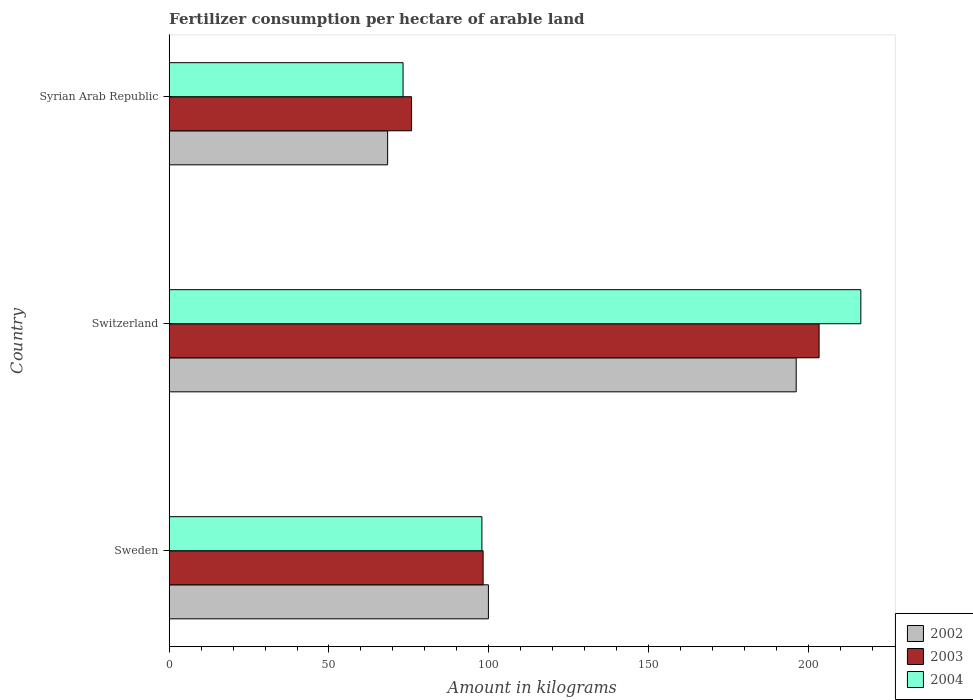How many bars are there on the 1st tick from the top?
Offer a very short reply. 3. What is the label of the 3rd group of bars from the top?
Offer a terse response. Sweden. What is the amount of fertilizer consumption in 2003 in Sweden?
Your response must be concise. 98.24. Across all countries, what is the maximum amount of fertilizer consumption in 2003?
Keep it short and to the point. 203.37. Across all countries, what is the minimum amount of fertilizer consumption in 2003?
Offer a very short reply. 75.85. In which country was the amount of fertilizer consumption in 2003 maximum?
Ensure brevity in your answer.  Switzerland. In which country was the amount of fertilizer consumption in 2004 minimum?
Your response must be concise. Syrian Arab Republic. What is the total amount of fertilizer consumption in 2002 in the graph?
Offer a very short reply. 364.45. What is the difference between the amount of fertilizer consumption in 2003 in Sweden and that in Syrian Arab Republic?
Offer a terse response. 22.39. What is the difference between the amount of fertilizer consumption in 2003 in Syrian Arab Republic and the amount of fertilizer consumption in 2002 in Sweden?
Your answer should be very brief. -24.04. What is the average amount of fertilizer consumption in 2002 per country?
Provide a succinct answer. 121.48. What is the difference between the amount of fertilizer consumption in 2003 and amount of fertilizer consumption in 2004 in Syrian Arab Republic?
Keep it short and to the point. 2.67. In how many countries, is the amount of fertilizer consumption in 2002 greater than 170 kg?
Your answer should be very brief. 1. What is the ratio of the amount of fertilizer consumption in 2002 in Switzerland to that in Syrian Arab Republic?
Give a very brief answer. 2.87. What is the difference between the highest and the second highest amount of fertilizer consumption in 2003?
Keep it short and to the point. 105.13. What is the difference between the highest and the lowest amount of fertilizer consumption in 2002?
Offer a terse response. 127.85. In how many countries, is the amount of fertilizer consumption in 2002 greater than the average amount of fertilizer consumption in 2002 taken over all countries?
Your response must be concise. 1. What does the 1st bar from the top in Syrian Arab Republic represents?
Offer a very short reply. 2004. What does the 2nd bar from the bottom in Syrian Arab Republic represents?
Your response must be concise. 2003. Is it the case that in every country, the sum of the amount of fertilizer consumption in 2004 and amount of fertilizer consumption in 2002 is greater than the amount of fertilizer consumption in 2003?
Make the answer very short. Yes. How many bars are there?
Offer a very short reply. 9. Are all the bars in the graph horizontal?
Keep it short and to the point. Yes. How many countries are there in the graph?
Your answer should be very brief. 3. Are the values on the major ticks of X-axis written in scientific E-notation?
Provide a succinct answer. No. Does the graph contain any zero values?
Your response must be concise. No. Does the graph contain grids?
Your answer should be very brief. No. Where does the legend appear in the graph?
Provide a short and direct response. Bottom right. How many legend labels are there?
Keep it short and to the point. 3. How are the legend labels stacked?
Your answer should be very brief. Vertical. What is the title of the graph?
Your answer should be very brief. Fertilizer consumption per hectare of arable land. Does "2006" appear as one of the legend labels in the graph?
Offer a terse response. No. What is the label or title of the X-axis?
Provide a succinct answer. Amount in kilograms. What is the label or title of the Y-axis?
Your answer should be very brief. Country. What is the Amount in kilograms in 2002 in Sweden?
Your answer should be compact. 99.89. What is the Amount in kilograms of 2003 in Sweden?
Make the answer very short. 98.24. What is the Amount in kilograms in 2004 in Sweden?
Your answer should be compact. 97.85. What is the Amount in kilograms of 2002 in Switzerland?
Give a very brief answer. 196.21. What is the Amount in kilograms of 2003 in Switzerland?
Your answer should be compact. 203.37. What is the Amount in kilograms in 2004 in Switzerland?
Give a very brief answer. 216.44. What is the Amount in kilograms of 2002 in Syrian Arab Republic?
Provide a short and direct response. 68.35. What is the Amount in kilograms in 2003 in Syrian Arab Republic?
Provide a succinct answer. 75.85. What is the Amount in kilograms in 2004 in Syrian Arab Republic?
Offer a very short reply. 73.18. Across all countries, what is the maximum Amount in kilograms in 2002?
Ensure brevity in your answer.  196.21. Across all countries, what is the maximum Amount in kilograms in 2003?
Ensure brevity in your answer.  203.37. Across all countries, what is the maximum Amount in kilograms of 2004?
Ensure brevity in your answer.  216.44. Across all countries, what is the minimum Amount in kilograms in 2002?
Make the answer very short. 68.35. Across all countries, what is the minimum Amount in kilograms of 2003?
Your answer should be compact. 75.85. Across all countries, what is the minimum Amount in kilograms in 2004?
Your response must be concise. 73.18. What is the total Amount in kilograms in 2002 in the graph?
Provide a succinct answer. 364.45. What is the total Amount in kilograms in 2003 in the graph?
Give a very brief answer. 377.46. What is the total Amount in kilograms in 2004 in the graph?
Give a very brief answer. 387.47. What is the difference between the Amount in kilograms in 2002 in Sweden and that in Switzerland?
Your answer should be very brief. -96.32. What is the difference between the Amount in kilograms in 2003 in Sweden and that in Switzerland?
Provide a succinct answer. -105.13. What is the difference between the Amount in kilograms in 2004 in Sweden and that in Switzerland?
Give a very brief answer. -118.58. What is the difference between the Amount in kilograms in 2002 in Sweden and that in Syrian Arab Republic?
Keep it short and to the point. 31.54. What is the difference between the Amount in kilograms of 2003 in Sweden and that in Syrian Arab Republic?
Give a very brief answer. 22.39. What is the difference between the Amount in kilograms in 2004 in Sweden and that in Syrian Arab Republic?
Give a very brief answer. 24.67. What is the difference between the Amount in kilograms of 2002 in Switzerland and that in Syrian Arab Republic?
Keep it short and to the point. 127.85. What is the difference between the Amount in kilograms of 2003 in Switzerland and that in Syrian Arab Republic?
Keep it short and to the point. 127.52. What is the difference between the Amount in kilograms of 2004 in Switzerland and that in Syrian Arab Republic?
Offer a terse response. 143.26. What is the difference between the Amount in kilograms in 2002 in Sweden and the Amount in kilograms in 2003 in Switzerland?
Your response must be concise. -103.48. What is the difference between the Amount in kilograms of 2002 in Sweden and the Amount in kilograms of 2004 in Switzerland?
Your answer should be very brief. -116.55. What is the difference between the Amount in kilograms in 2003 in Sweden and the Amount in kilograms in 2004 in Switzerland?
Provide a succinct answer. -118.2. What is the difference between the Amount in kilograms in 2002 in Sweden and the Amount in kilograms in 2003 in Syrian Arab Republic?
Offer a terse response. 24.04. What is the difference between the Amount in kilograms in 2002 in Sweden and the Amount in kilograms in 2004 in Syrian Arab Republic?
Your answer should be compact. 26.71. What is the difference between the Amount in kilograms in 2003 in Sweden and the Amount in kilograms in 2004 in Syrian Arab Republic?
Make the answer very short. 25.06. What is the difference between the Amount in kilograms in 2002 in Switzerland and the Amount in kilograms in 2003 in Syrian Arab Republic?
Give a very brief answer. 120.36. What is the difference between the Amount in kilograms of 2002 in Switzerland and the Amount in kilograms of 2004 in Syrian Arab Republic?
Provide a succinct answer. 123.03. What is the difference between the Amount in kilograms of 2003 in Switzerland and the Amount in kilograms of 2004 in Syrian Arab Republic?
Offer a terse response. 130.19. What is the average Amount in kilograms in 2002 per country?
Make the answer very short. 121.48. What is the average Amount in kilograms of 2003 per country?
Make the answer very short. 125.82. What is the average Amount in kilograms of 2004 per country?
Make the answer very short. 129.16. What is the difference between the Amount in kilograms in 2002 and Amount in kilograms in 2003 in Sweden?
Give a very brief answer. 1.65. What is the difference between the Amount in kilograms in 2002 and Amount in kilograms in 2004 in Sweden?
Ensure brevity in your answer.  2.03. What is the difference between the Amount in kilograms in 2003 and Amount in kilograms in 2004 in Sweden?
Offer a very short reply. 0.38. What is the difference between the Amount in kilograms in 2002 and Amount in kilograms in 2003 in Switzerland?
Provide a succinct answer. -7.16. What is the difference between the Amount in kilograms in 2002 and Amount in kilograms in 2004 in Switzerland?
Make the answer very short. -20.23. What is the difference between the Amount in kilograms of 2003 and Amount in kilograms of 2004 in Switzerland?
Provide a short and direct response. -13.07. What is the difference between the Amount in kilograms in 2002 and Amount in kilograms in 2003 in Syrian Arab Republic?
Ensure brevity in your answer.  -7.5. What is the difference between the Amount in kilograms in 2002 and Amount in kilograms in 2004 in Syrian Arab Republic?
Offer a very short reply. -4.83. What is the difference between the Amount in kilograms of 2003 and Amount in kilograms of 2004 in Syrian Arab Republic?
Ensure brevity in your answer.  2.67. What is the ratio of the Amount in kilograms in 2002 in Sweden to that in Switzerland?
Offer a very short reply. 0.51. What is the ratio of the Amount in kilograms of 2003 in Sweden to that in Switzerland?
Keep it short and to the point. 0.48. What is the ratio of the Amount in kilograms of 2004 in Sweden to that in Switzerland?
Make the answer very short. 0.45. What is the ratio of the Amount in kilograms in 2002 in Sweden to that in Syrian Arab Republic?
Provide a succinct answer. 1.46. What is the ratio of the Amount in kilograms in 2003 in Sweden to that in Syrian Arab Republic?
Give a very brief answer. 1.3. What is the ratio of the Amount in kilograms in 2004 in Sweden to that in Syrian Arab Republic?
Keep it short and to the point. 1.34. What is the ratio of the Amount in kilograms of 2002 in Switzerland to that in Syrian Arab Republic?
Make the answer very short. 2.87. What is the ratio of the Amount in kilograms in 2003 in Switzerland to that in Syrian Arab Republic?
Your answer should be very brief. 2.68. What is the ratio of the Amount in kilograms in 2004 in Switzerland to that in Syrian Arab Republic?
Give a very brief answer. 2.96. What is the difference between the highest and the second highest Amount in kilograms of 2002?
Your response must be concise. 96.32. What is the difference between the highest and the second highest Amount in kilograms in 2003?
Keep it short and to the point. 105.13. What is the difference between the highest and the second highest Amount in kilograms of 2004?
Your answer should be compact. 118.58. What is the difference between the highest and the lowest Amount in kilograms of 2002?
Offer a very short reply. 127.85. What is the difference between the highest and the lowest Amount in kilograms of 2003?
Your answer should be very brief. 127.52. What is the difference between the highest and the lowest Amount in kilograms in 2004?
Offer a very short reply. 143.26. 